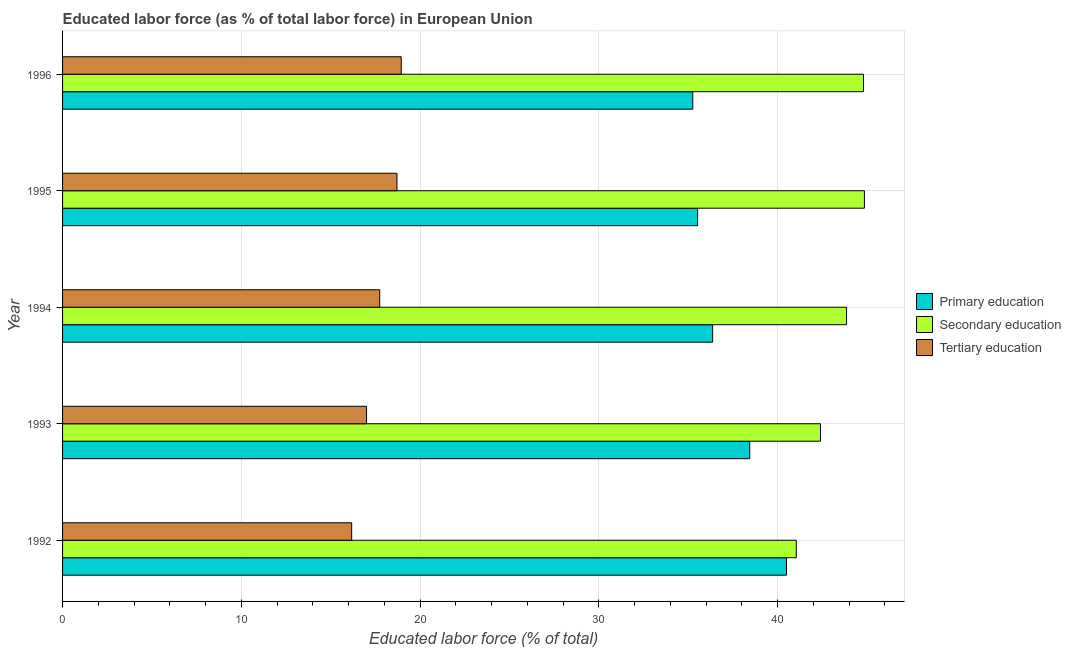How many bars are there on the 1st tick from the top?
Your answer should be very brief. 3. What is the label of the 3rd group of bars from the top?
Your answer should be compact. 1994. What is the percentage of labor force who received tertiary education in 1996?
Offer a terse response. 18.94. Across all years, what is the maximum percentage of labor force who received primary education?
Provide a succinct answer. 40.49. Across all years, what is the minimum percentage of labor force who received tertiary education?
Ensure brevity in your answer.  16.17. What is the total percentage of labor force who received secondary education in the graph?
Keep it short and to the point. 216.95. What is the difference between the percentage of labor force who received primary education in 1994 and that in 1996?
Your answer should be compact. 1.11. What is the difference between the percentage of labor force who received primary education in 1995 and the percentage of labor force who received tertiary education in 1996?
Give a very brief answer. 16.58. What is the average percentage of labor force who received tertiary education per year?
Offer a very short reply. 17.71. In the year 1996, what is the difference between the percentage of labor force who received primary education and percentage of labor force who received secondary education?
Offer a very short reply. -9.55. In how many years, is the percentage of labor force who received tertiary education greater than 4 %?
Your response must be concise. 5. Is the difference between the percentage of labor force who received primary education in 1992 and 1996 greater than the difference between the percentage of labor force who received tertiary education in 1992 and 1996?
Ensure brevity in your answer.  Yes. What is the difference between the highest and the second highest percentage of labor force who received tertiary education?
Make the answer very short. 0.24. What is the difference between the highest and the lowest percentage of labor force who received tertiary education?
Ensure brevity in your answer.  2.77. Is it the case that in every year, the sum of the percentage of labor force who received primary education and percentage of labor force who received secondary education is greater than the percentage of labor force who received tertiary education?
Ensure brevity in your answer.  Yes. How many bars are there?
Give a very brief answer. 15. What is the difference between two consecutive major ticks on the X-axis?
Offer a very short reply. 10. Does the graph contain grids?
Keep it short and to the point. Yes. How many legend labels are there?
Give a very brief answer. 3. How are the legend labels stacked?
Offer a very short reply. Vertical. What is the title of the graph?
Ensure brevity in your answer.  Educated labor force (as % of total labor force) in European Union. Does "Social insurance" appear as one of the legend labels in the graph?
Your answer should be compact. No. What is the label or title of the X-axis?
Give a very brief answer. Educated labor force (% of total). What is the label or title of the Y-axis?
Ensure brevity in your answer.  Year. What is the Educated labor force (% of total) in Primary education in 1992?
Your answer should be very brief. 40.49. What is the Educated labor force (% of total) of Secondary education in 1992?
Provide a short and direct response. 41.04. What is the Educated labor force (% of total) in Tertiary education in 1992?
Your answer should be compact. 16.17. What is the Educated labor force (% of total) of Primary education in 1993?
Provide a succinct answer. 38.44. What is the Educated labor force (% of total) of Secondary education in 1993?
Ensure brevity in your answer.  42.4. What is the Educated labor force (% of total) in Tertiary education in 1993?
Your response must be concise. 17. What is the Educated labor force (% of total) in Primary education in 1994?
Offer a very short reply. 36.36. What is the Educated labor force (% of total) in Secondary education in 1994?
Offer a very short reply. 43.85. What is the Educated labor force (% of total) in Tertiary education in 1994?
Offer a very short reply. 17.74. What is the Educated labor force (% of total) in Primary education in 1995?
Provide a succinct answer. 35.52. What is the Educated labor force (% of total) of Secondary education in 1995?
Give a very brief answer. 44.85. What is the Educated labor force (% of total) in Tertiary education in 1995?
Keep it short and to the point. 18.7. What is the Educated labor force (% of total) in Primary education in 1996?
Your answer should be very brief. 35.25. What is the Educated labor force (% of total) of Secondary education in 1996?
Ensure brevity in your answer.  44.8. What is the Educated labor force (% of total) in Tertiary education in 1996?
Offer a very short reply. 18.94. Across all years, what is the maximum Educated labor force (% of total) in Primary education?
Your answer should be compact. 40.49. Across all years, what is the maximum Educated labor force (% of total) of Secondary education?
Make the answer very short. 44.85. Across all years, what is the maximum Educated labor force (% of total) of Tertiary education?
Ensure brevity in your answer.  18.94. Across all years, what is the minimum Educated labor force (% of total) of Primary education?
Your answer should be compact. 35.25. Across all years, what is the minimum Educated labor force (% of total) of Secondary education?
Offer a very short reply. 41.04. Across all years, what is the minimum Educated labor force (% of total) in Tertiary education?
Ensure brevity in your answer.  16.17. What is the total Educated labor force (% of total) in Primary education in the graph?
Offer a terse response. 186.07. What is the total Educated labor force (% of total) in Secondary education in the graph?
Offer a terse response. 216.95. What is the total Educated labor force (% of total) of Tertiary education in the graph?
Your response must be concise. 88.56. What is the difference between the Educated labor force (% of total) of Primary education in 1992 and that in 1993?
Provide a short and direct response. 2.06. What is the difference between the Educated labor force (% of total) of Secondary education in 1992 and that in 1993?
Your answer should be compact. -1.35. What is the difference between the Educated labor force (% of total) in Tertiary education in 1992 and that in 1993?
Your answer should be very brief. -0.83. What is the difference between the Educated labor force (% of total) in Primary education in 1992 and that in 1994?
Give a very brief answer. 4.13. What is the difference between the Educated labor force (% of total) in Secondary education in 1992 and that in 1994?
Make the answer very short. -2.81. What is the difference between the Educated labor force (% of total) in Tertiary education in 1992 and that in 1994?
Keep it short and to the point. -1.57. What is the difference between the Educated labor force (% of total) of Primary education in 1992 and that in 1995?
Make the answer very short. 4.97. What is the difference between the Educated labor force (% of total) of Secondary education in 1992 and that in 1995?
Give a very brief answer. -3.81. What is the difference between the Educated labor force (% of total) in Tertiary education in 1992 and that in 1995?
Keep it short and to the point. -2.53. What is the difference between the Educated labor force (% of total) of Primary education in 1992 and that in 1996?
Provide a short and direct response. 5.24. What is the difference between the Educated labor force (% of total) of Secondary education in 1992 and that in 1996?
Provide a short and direct response. -3.76. What is the difference between the Educated labor force (% of total) of Tertiary education in 1992 and that in 1996?
Your response must be concise. -2.77. What is the difference between the Educated labor force (% of total) of Primary education in 1993 and that in 1994?
Your answer should be very brief. 2.07. What is the difference between the Educated labor force (% of total) of Secondary education in 1993 and that in 1994?
Offer a very short reply. -1.46. What is the difference between the Educated labor force (% of total) in Tertiary education in 1993 and that in 1994?
Offer a terse response. -0.74. What is the difference between the Educated labor force (% of total) of Primary education in 1993 and that in 1995?
Provide a succinct answer. 2.91. What is the difference between the Educated labor force (% of total) in Secondary education in 1993 and that in 1995?
Give a very brief answer. -2.46. What is the difference between the Educated labor force (% of total) of Tertiary education in 1993 and that in 1995?
Your response must be concise. -1.7. What is the difference between the Educated labor force (% of total) of Primary education in 1993 and that in 1996?
Your answer should be very brief. 3.19. What is the difference between the Educated labor force (% of total) of Secondary education in 1993 and that in 1996?
Provide a succinct answer. -2.4. What is the difference between the Educated labor force (% of total) of Tertiary education in 1993 and that in 1996?
Your answer should be compact. -1.94. What is the difference between the Educated labor force (% of total) in Primary education in 1994 and that in 1995?
Your response must be concise. 0.84. What is the difference between the Educated labor force (% of total) of Secondary education in 1994 and that in 1995?
Offer a very short reply. -1. What is the difference between the Educated labor force (% of total) of Tertiary education in 1994 and that in 1995?
Your answer should be compact. -0.96. What is the difference between the Educated labor force (% of total) of Primary education in 1994 and that in 1996?
Make the answer very short. 1.11. What is the difference between the Educated labor force (% of total) in Secondary education in 1994 and that in 1996?
Ensure brevity in your answer.  -0.95. What is the difference between the Educated labor force (% of total) in Tertiary education in 1994 and that in 1996?
Your answer should be compact. -1.2. What is the difference between the Educated labor force (% of total) in Primary education in 1995 and that in 1996?
Provide a short and direct response. 0.27. What is the difference between the Educated labor force (% of total) of Secondary education in 1995 and that in 1996?
Ensure brevity in your answer.  0.05. What is the difference between the Educated labor force (% of total) of Tertiary education in 1995 and that in 1996?
Make the answer very short. -0.24. What is the difference between the Educated labor force (% of total) in Primary education in 1992 and the Educated labor force (% of total) in Secondary education in 1993?
Your answer should be compact. -1.9. What is the difference between the Educated labor force (% of total) of Primary education in 1992 and the Educated labor force (% of total) of Tertiary education in 1993?
Offer a very short reply. 23.49. What is the difference between the Educated labor force (% of total) of Secondary education in 1992 and the Educated labor force (% of total) of Tertiary education in 1993?
Provide a succinct answer. 24.04. What is the difference between the Educated labor force (% of total) of Primary education in 1992 and the Educated labor force (% of total) of Secondary education in 1994?
Your answer should be very brief. -3.36. What is the difference between the Educated labor force (% of total) of Primary education in 1992 and the Educated labor force (% of total) of Tertiary education in 1994?
Ensure brevity in your answer.  22.76. What is the difference between the Educated labor force (% of total) in Secondary education in 1992 and the Educated labor force (% of total) in Tertiary education in 1994?
Make the answer very short. 23.3. What is the difference between the Educated labor force (% of total) of Primary education in 1992 and the Educated labor force (% of total) of Secondary education in 1995?
Offer a very short reply. -4.36. What is the difference between the Educated labor force (% of total) in Primary education in 1992 and the Educated labor force (% of total) in Tertiary education in 1995?
Make the answer very short. 21.79. What is the difference between the Educated labor force (% of total) of Secondary education in 1992 and the Educated labor force (% of total) of Tertiary education in 1995?
Make the answer very short. 22.34. What is the difference between the Educated labor force (% of total) in Primary education in 1992 and the Educated labor force (% of total) in Secondary education in 1996?
Offer a very short reply. -4.31. What is the difference between the Educated labor force (% of total) of Primary education in 1992 and the Educated labor force (% of total) of Tertiary education in 1996?
Offer a very short reply. 21.55. What is the difference between the Educated labor force (% of total) in Secondary education in 1992 and the Educated labor force (% of total) in Tertiary education in 1996?
Offer a very short reply. 22.1. What is the difference between the Educated labor force (% of total) of Primary education in 1993 and the Educated labor force (% of total) of Secondary education in 1994?
Ensure brevity in your answer.  -5.42. What is the difference between the Educated labor force (% of total) in Primary education in 1993 and the Educated labor force (% of total) in Tertiary education in 1994?
Give a very brief answer. 20.7. What is the difference between the Educated labor force (% of total) of Secondary education in 1993 and the Educated labor force (% of total) of Tertiary education in 1994?
Make the answer very short. 24.66. What is the difference between the Educated labor force (% of total) in Primary education in 1993 and the Educated labor force (% of total) in Secondary education in 1995?
Offer a very short reply. -6.42. What is the difference between the Educated labor force (% of total) of Primary education in 1993 and the Educated labor force (% of total) of Tertiary education in 1995?
Ensure brevity in your answer.  19.73. What is the difference between the Educated labor force (% of total) in Secondary education in 1993 and the Educated labor force (% of total) in Tertiary education in 1995?
Your response must be concise. 23.69. What is the difference between the Educated labor force (% of total) in Primary education in 1993 and the Educated labor force (% of total) in Secondary education in 1996?
Make the answer very short. -6.37. What is the difference between the Educated labor force (% of total) of Primary education in 1993 and the Educated labor force (% of total) of Tertiary education in 1996?
Your response must be concise. 19.49. What is the difference between the Educated labor force (% of total) of Secondary education in 1993 and the Educated labor force (% of total) of Tertiary education in 1996?
Ensure brevity in your answer.  23.45. What is the difference between the Educated labor force (% of total) in Primary education in 1994 and the Educated labor force (% of total) in Secondary education in 1995?
Make the answer very short. -8.49. What is the difference between the Educated labor force (% of total) in Primary education in 1994 and the Educated labor force (% of total) in Tertiary education in 1995?
Your answer should be compact. 17.66. What is the difference between the Educated labor force (% of total) of Secondary education in 1994 and the Educated labor force (% of total) of Tertiary education in 1995?
Offer a very short reply. 25.15. What is the difference between the Educated labor force (% of total) in Primary education in 1994 and the Educated labor force (% of total) in Secondary education in 1996?
Provide a succinct answer. -8.44. What is the difference between the Educated labor force (% of total) in Primary education in 1994 and the Educated labor force (% of total) in Tertiary education in 1996?
Your response must be concise. 17.42. What is the difference between the Educated labor force (% of total) of Secondary education in 1994 and the Educated labor force (% of total) of Tertiary education in 1996?
Offer a very short reply. 24.91. What is the difference between the Educated labor force (% of total) in Primary education in 1995 and the Educated labor force (% of total) in Secondary education in 1996?
Make the answer very short. -9.28. What is the difference between the Educated labor force (% of total) of Primary education in 1995 and the Educated labor force (% of total) of Tertiary education in 1996?
Keep it short and to the point. 16.58. What is the difference between the Educated labor force (% of total) of Secondary education in 1995 and the Educated labor force (% of total) of Tertiary education in 1996?
Offer a terse response. 25.91. What is the average Educated labor force (% of total) in Primary education per year?
Your answer should be very brief. 37.21. What is the average Educated labor force (% of total) of Secondary education per year?
Make the answer very short. 43.39. What is the average Educated labor force (% of total) in Tertiary education per year?
Your response must be concise. 17.71. In the year 1992, what is the difference between the Educated labor force (% of total) of Primary education and Educated labor force (% of total) of Secondary education?
Your answer should be very brief. -0.55. In the year 1992, what is the difference between the Educated labor force (% of total) of Primary education and Educated labor force (% of total) of Tertiary education?
Offer a terse response. 24.32. In the year 1992, what is the difference between the Educated labor force (% of total) of Secondary education and Educated labor force (% of total) of Tertiary education?
Keep it short and to the point. 24.87. In the year 1993, what is the difference between the Educated labor force (% of total) of Primary education and Educated labor force (% of total) of Secondary education?
Make the answer very short. -3.96. In the year 1993, what is the difference between the Educated labor force (% of total) of Primary education and Educated labor force (% of total) of Tertiary education?
Your answer should be very brief. 21.43. In the year 1993, what is the difference between the Educated labor force (% of total) of Secondary education and Educated labor force (% of total) of Tertiary education?
Provide a short and direct response. 25.39. In the year 1994, what is the difference between the Educated labor force (% of total) of Primary education and Educated labor force (% of total) of Secondary education?
Offer a very short reply. -7.49. In the year 1994, what is the difference between the Educated labor force (% of total) in Primary education and Educated labor force (% of total) in Tertiary education?
Offer a terse response. 18.62. In the year 1994, what is the difference between the Educated labor force (% of total) of Secondary education and Educated labor force (% of total) of Tertiary education?
Offer a terse response. 26.11. In the year 1995, what is the difference between the Educated labor force (% of total) of Primary education and Educated labor force (% of total) of Secondary education?
Offer a very short reply. -9.33. In the year 1995, what is the difference between the Educated labor force (% of total) of Primary education and Educated labor force (% of total) of Tertiary education?
Offer a terse response. 16.82. In the year 1995, what is the difference between the Educated labor force (% of total) in Secondary education and Educated labor force (% of total) in Tertiary education?
Offer a very short reply. 26.15. In the year 1996, what is the difference between the Educated labor force (% of total) in Primary education and Educated labor force (% of total) in Secondary education?
Provide a short and direct response. -9.55. In the year 1996, what is the difference between the Educated labor force (% of total) of Primary education and Educated labor force (% of total) of Tertiary education?
Your answer should be very brief. 16.31. In the year 1996, what is the difference between the Educated labor force (% of total) of Secondary education and Educated labor force (% of total) of Tertiary education?
Your answer should be very brief. 25.86. What is the ratio of the Educated labor force (% of total) of Primary education in 1992 to that in 1993?
Ensure brevity in your answer.  1.05. What is the ratio of the Educated labor force (% of total) in Secondary education in 1992 to that in 1993?
Provide a succinct answer. 0.97. What is the ratio of the Educated labor force (% of total) in Tertiary education in 1992 to that in 1993?
Ensure brevity in your answer.  0.95. What is the ratio of the Educated labor force (% of total) in Primary education in 1992 to that in 1994?
Ensure brevity in your answer.  1.11. What is the ratio of the Educated labor force (% of total) in Secondary education in 1992 to that in 1994?
Your answer should be compact. 0.94. What is the ratio of the Educated labor force (% of total) in Tertiary education in 1992 to that in 1994?
Provide a succinct answer. 0.91. What is the ratio of the Educated labor force (% of total) of Primary education in 1992 to that in 1995?
Keep it short and to the point. 1.14. What is the ratio of the Educated labor force (% of total) of Secondary education in 1992 to that in 1995?
Ensure brevity in your answer.  0.92. What is the ratio of the Educated labor force (% of total) of Tertiary education in 1992 to that in 1995?
Give a very brief answer. 0.86. What is the ratio of the Educated labor force (% of total) of Primary education in 1992 to that in 1996?
Make the answer very short. 1.15. What is the ratio of the Educated labor force (% of total) of Secondary education in 1992 to that in 1996?
Your answer should be very brief. 0.92. What is the ratio of the Educated labor force (% of total) in Tertiary education in 1992 to that in 1996?
Your response must be concise. 0.85. What is the ratio of the Educated labor force (% of total) in Primary education in 1993 to that in 1994?
Your answer should be very brief. 1.06. What is the ratio of the Educated labor force (% of total) of Secondary education in 1993 to that in 1994?
Keep it short and to the point. 0.97. What is the ratio of the Educated labor force (% of total) of Tertiary education in 1993 to that in 1994?
Offer a terse response. 0.96. What is the ratio of the Educated labor force (% of total) in Primary education in 1993 to that in 1995?
Your response must be concise. 1.08. What is the ratio of the Educated labor force (% of total) in Secondary education in 1993 to that in 1995?
Offer a very short reply. 0.95. What is the ratio of the Educated labor force (% of total) of Primary education in 1993 to that in 1996?
Make the answer very short. 1.09. What is the ratio of the Educated labor force (% of total) of Secondary education in 1993 to that in 1996?
Give a very brief answer. 0.95. What is the ratio of the Educated labor force (% of total) of Tertiary education in 1993 to that in 1996?
Your answer should be very brief. 0.9. What is the ratio of the Educated labor force (% of total) in Primary education in 1994 to that in 1995?
Give a very brief answer. 1.02. What is the ratio of the Educated labor force (% of total) in Secondary education in 1994 to that in 1995?
Your answer should be compact. 0.98. What is the ratio of the Educated labor force (% of total) in Tertiary education in 1994 to that in 1995?
Give a very brief answer. 0.95. What is the ratio of the Educated labor force (% of total) of Primary education in 1994 to that in 1996?
Provide a succinct answer. 1.03. What is the ratio of the Educated labor force (% of total) in Secondary education in 1994 to that in 1996?
Provide a short and direct response. 0.98. What is the ratio of the Educated labor force (% of total) in Tertiary education in 1994 to that in 1996?
Keep it short and to the point. 0.94. What is the ratio of the Educated labor force (% of total) in Primary education in 1995 to that in 1996?
Offer a terse response. 1.01. What is the ratio of the Educated labor force (% of total) in Tertiary education in 1995 to that in 1996?
Keep it short and to the point. 0.99. What is the difference between the highest and the second highest Educated labor force (% of total) in Primary education?
Provide a short and direct response. 2.06. What is the difference between the highest and the second highest Educated labor force (% of total) in Secondary education?
Your answer should be compact. 0.05. What is the difference between the highest and the second highest Educated labor force (% of total) in Tertiary education?
Give a very brief answer. 0.24. What is the difference between the highest and the lowest Educated labor force (% of total) of Primary education?
Offer a terse response. 5.24. What is the difference between the highest and the lowest Educated labor force (% of total) in Secondary education?
Provide a succinct answer. 3.81. What is the difference between the highest and the lowest Educated labor force (% of total) of Tertiary education?
Ensure brevity in your answer.  2.77. 